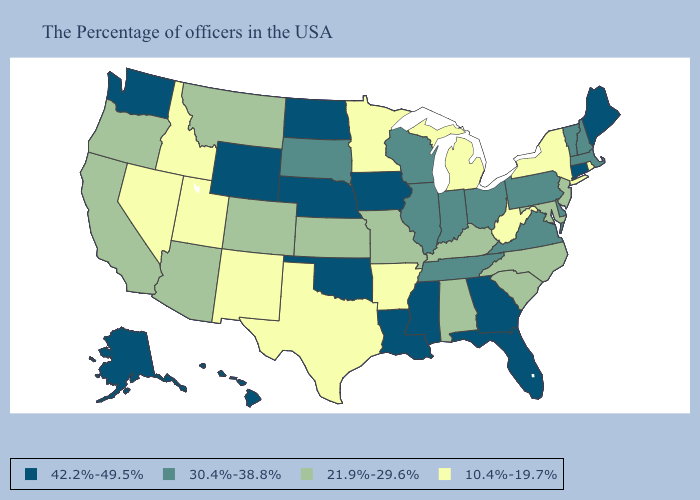What is the value of Illinois?
Concise answer only. 30.4%-38.8%. Does Oregon have a higher value than Kansas?
Keep it brief. No. What is the highest value in the MidWest ?
Give a very brief answer. 42.2%-49.5%. Name the states that have a value in the range 42.2%-49.5%?
Write a very short answer. Maine, Connecticut, Florida, Georgia, Mississippi, Louisiana, Iowa, Nebraska, Oklahoma, North Dakota, Wyoming, Washington, Alaska, Hawaii. What is the highest value in the South ?
Be succinct. 42.2%-49.5%. Which states have the highest value in the USA?
Answer briefly. Maine, Connecticut, Florida, Georgia, Mississippi, Louisiana, Iowa, Nebraska, Oklahoma, North Dakota, Wyoming, Washington, Alaska, Hawaii. Does the map have missing data?
Write a very short answer. No. Name the states that have a value in the range 42.2%-49.5%?
Concise answer only. Maine, Connecticut, Florida, Georgia, Mississippi, Louisiana, Iowa, Nebraska, Oklahoma, North Dakota, Wyoming, Washington, Alaska, Hawaii. What is the lowest value in states that border Rhode Island?
Write a very short answer. 30.4%-38.8%. Which states have the lowest value in the South?
Give a very brief answer. West Virginia, Arkansas, Texas. How many symbols are there in the legend?
Be succinct. 4. Which states have the lowest value in the USA?
Write a very short answer. Rhode Island, New York, West Virginia, Michigan, Arkansas, Minnesota, Texas, New Mexico, Utah, Idaho, Nevada. Does New Mexico have the lowest value in the USA?
Concise answer only. Yes. Which states have the highest value in the USA?
Short answer required. Maine, Connecticut, Florida, Georgia, Mississippi, Louisiana, Iowa, Nebraska, Oklahoma, North Dakota, Wyoming, Washington, Alaska, Hawaii. Does Louisiana have a higher value than West Virginia?
Short answer required. Yes. 